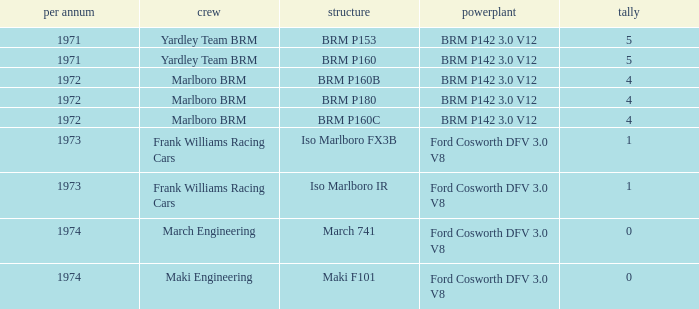Which chassis has marlboro brm as the team? BRM P160B, BRM P180, BRM P160C. 